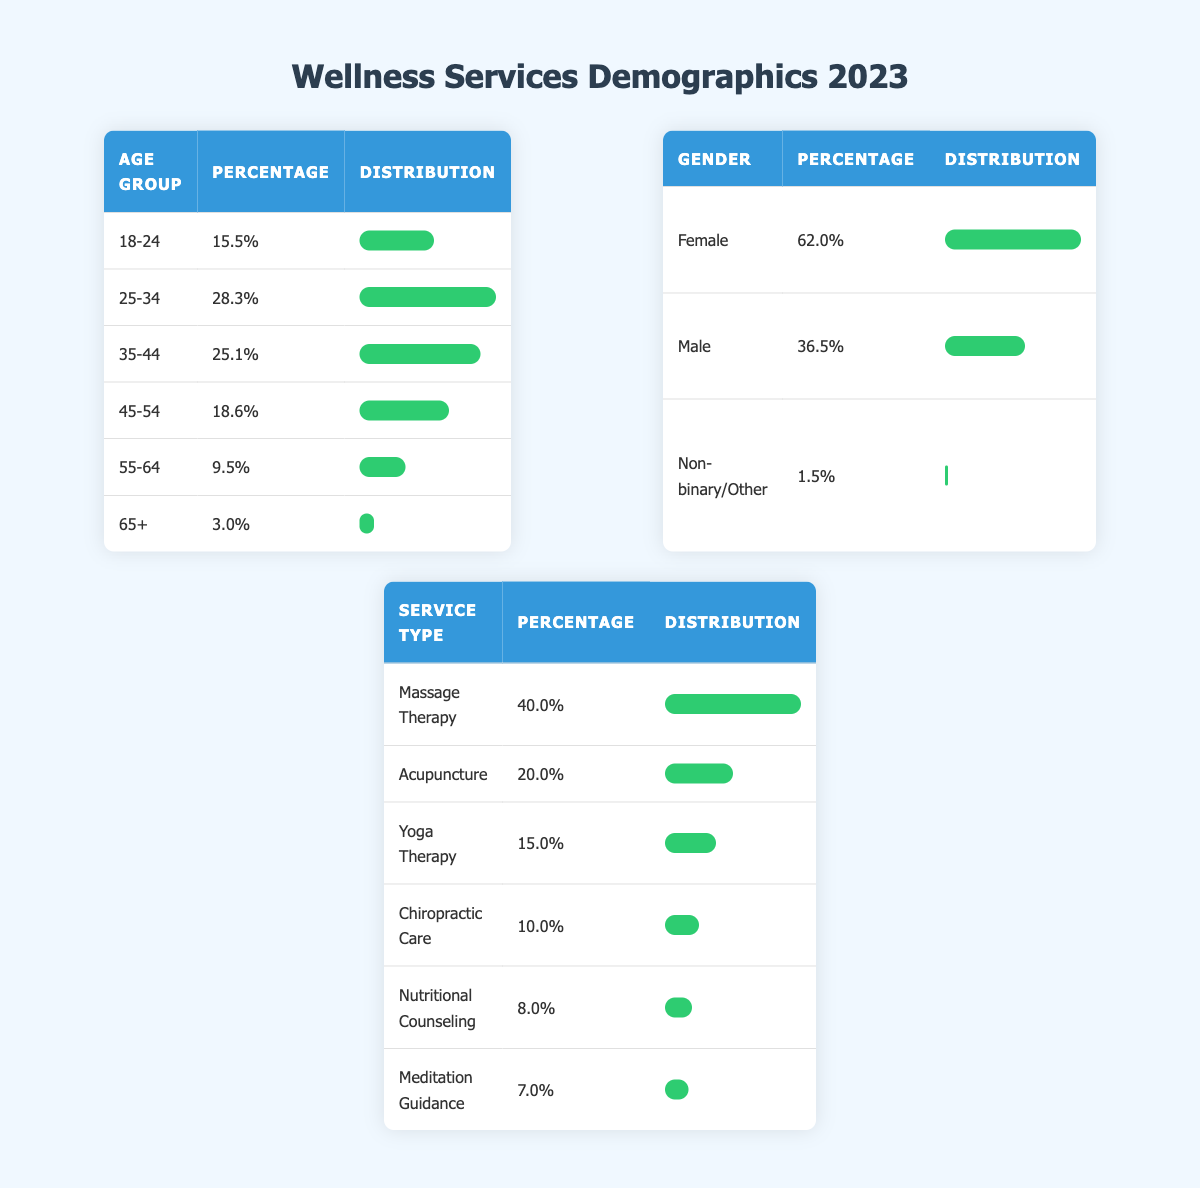What percentage of clients are aged 35-44? Referring to the age group table, the percentage of clients in the age group 35-44 is explicitly listed as 25.1%.
Answer: 25.1% Which age group has the highest percentage of clients? By comparing all the age groups, 25-34 has the highest percentage at 28.3%.
Answer: 25-34 What is the combined percentage of clients who prefer Massage Therapy and Acupuncture? The percentages for Massage Therapy (40.0%) and Acupuncture (20.0%) need to be added together: 40.0 + 20.0 = 60.0%.
Answer: 60.0% Is the majority of clients female? The gender breakdown shows that 62.0% of clients are female,which is greater than 50%.
Answer: Yes What is the percentage difference between male and female clients? The percentage of female clients is 62.0% and male clients is 36.5%. The difference is calculated as 62.0 - 36.5 = 25.5%.
Answer: 25.5% Which service type is least preferred based on the table? The service types are ranked by their percentages. Nutritional Counseling has the lowest percentage at 8.0%.
Answer: Nutritional Counseling If we look at the top two service types, what percentage do they make up of total services offered? The top two service types are Massage Therapy (40.0%) and Acupuncture (20.0%). Adding these gives: 40.0 + 20.0 = 60.0%.
Answer: 60.0% What percentage of clients are aged 65 and older? The table specifies that clients aged 65 and older comprise 3.0% of the total client demographics.
Answer: 3.0% What is the total percentage of clients who identify as Non-binary or Other and those who are Male? To find this, add the percentages of Non-binary/Other (1.5%) and Male (36.5%): 1.5 + 36.5 = 38.0%.
Answer: 38.0% 